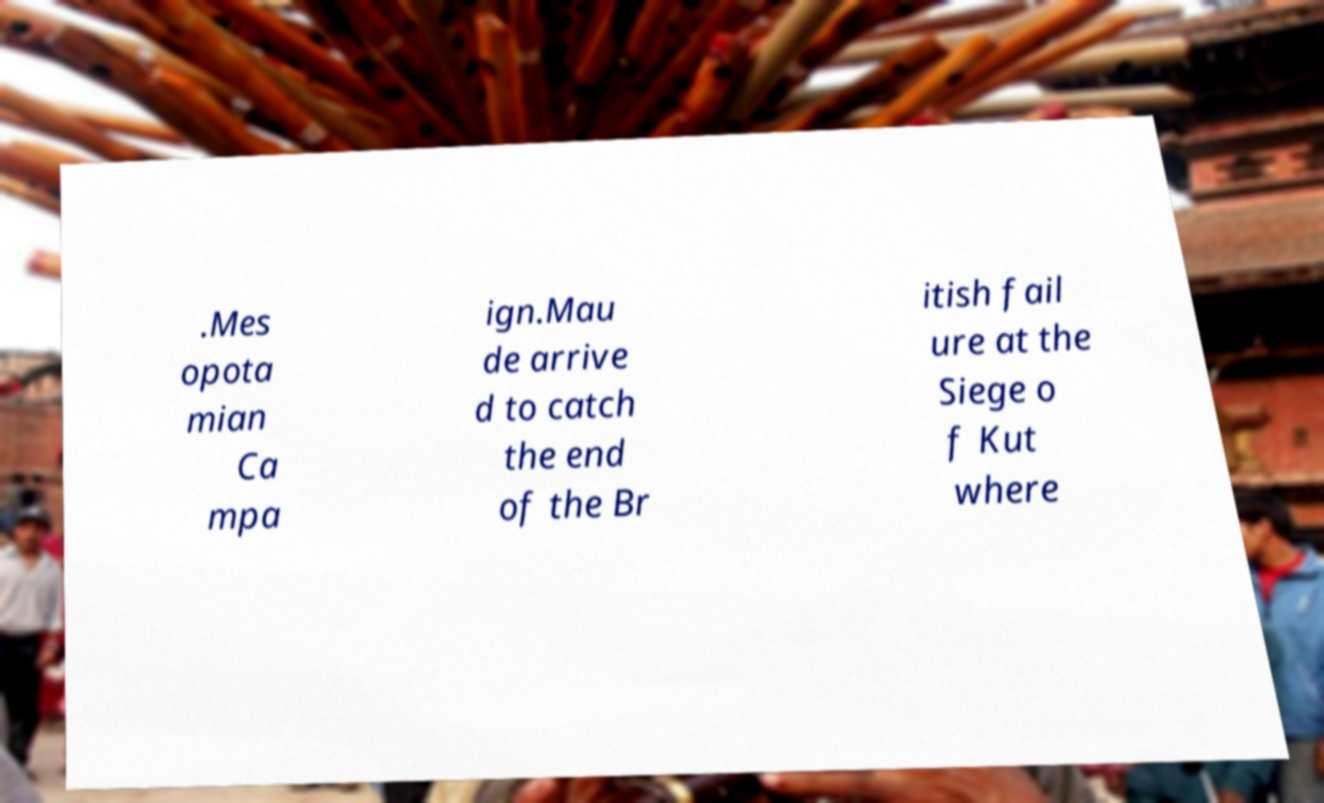There's text embedded in this image that I need extracted. Can you transcribe it verbatim? .Mes opota mian Ca mpa ign.Mau de arrive d to catch the end of the Br itish fail ure at the Siege o f Kut where 